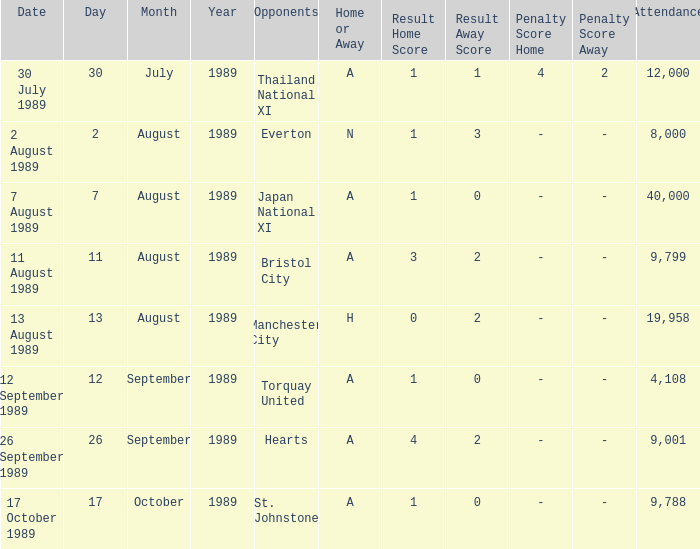How many people attended the match when Manchester United played against the Hearts? 9001.0. 